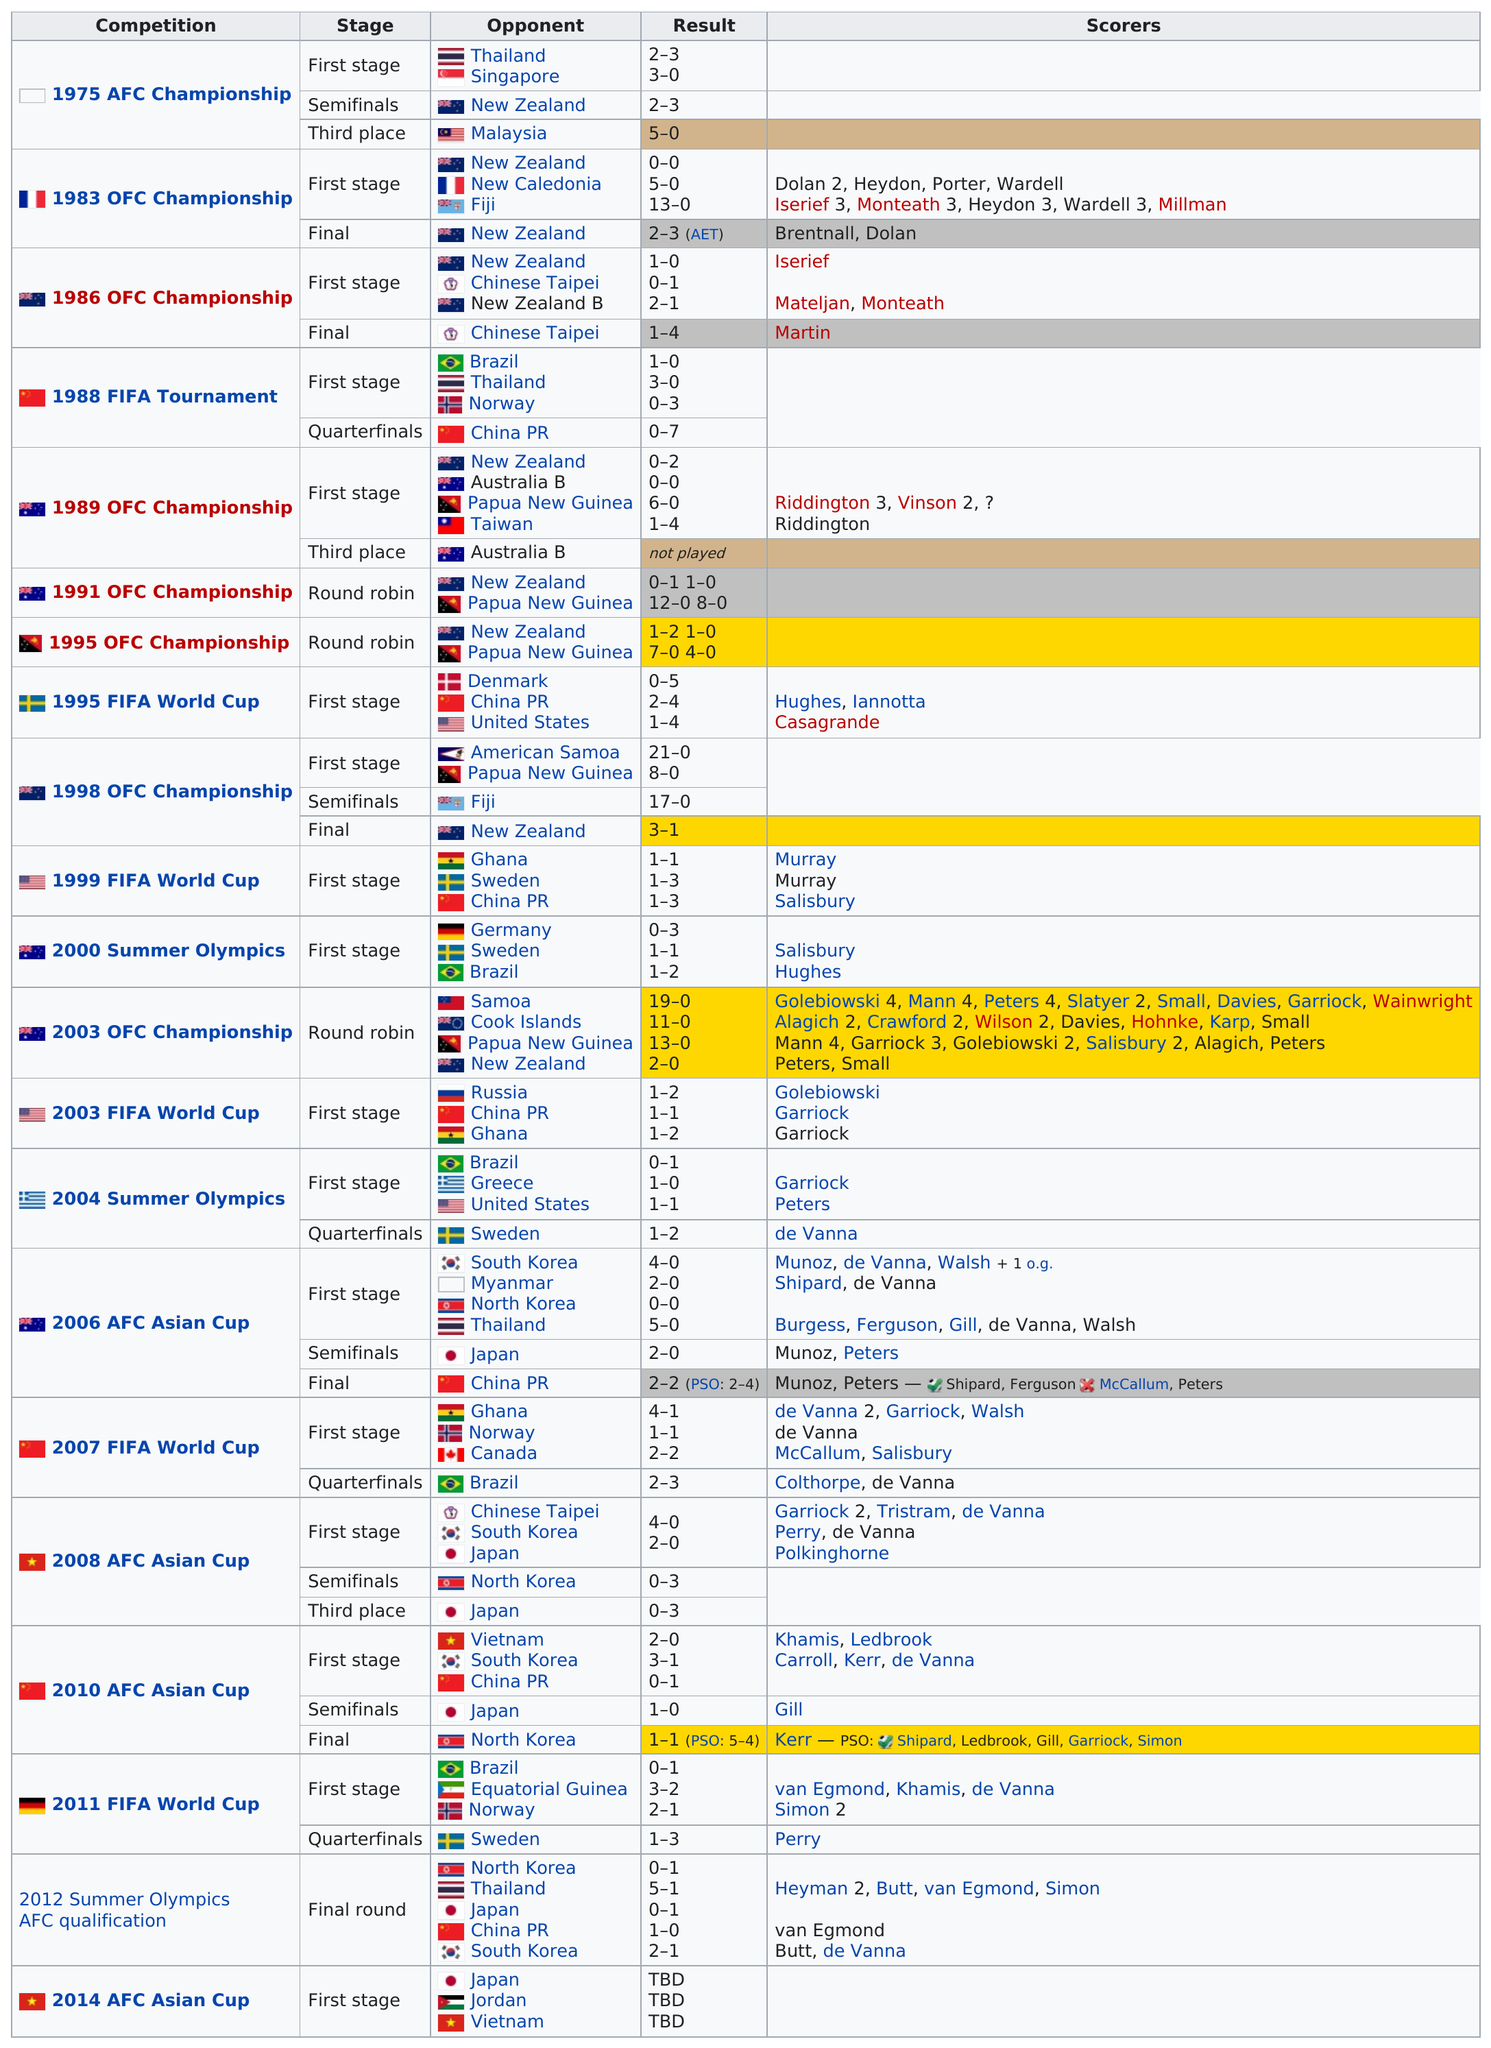Give some essential details in this illustration. The total number of competitions is 21. The first stage of the 2008 AFC Asian Cup included 4 countries. The number of stages in the round robin was 3, according to the given information. In the 1999 FIFA World Cup, a total of 146 goals were scored by the 32 participating teams, while in the 2000 Summer Olympics, a total of 72 goals were scored by the 10 participating men's soccer teams. The final round of the 2012 summer olympics AFC qualification resulted in 12 points being scored. 